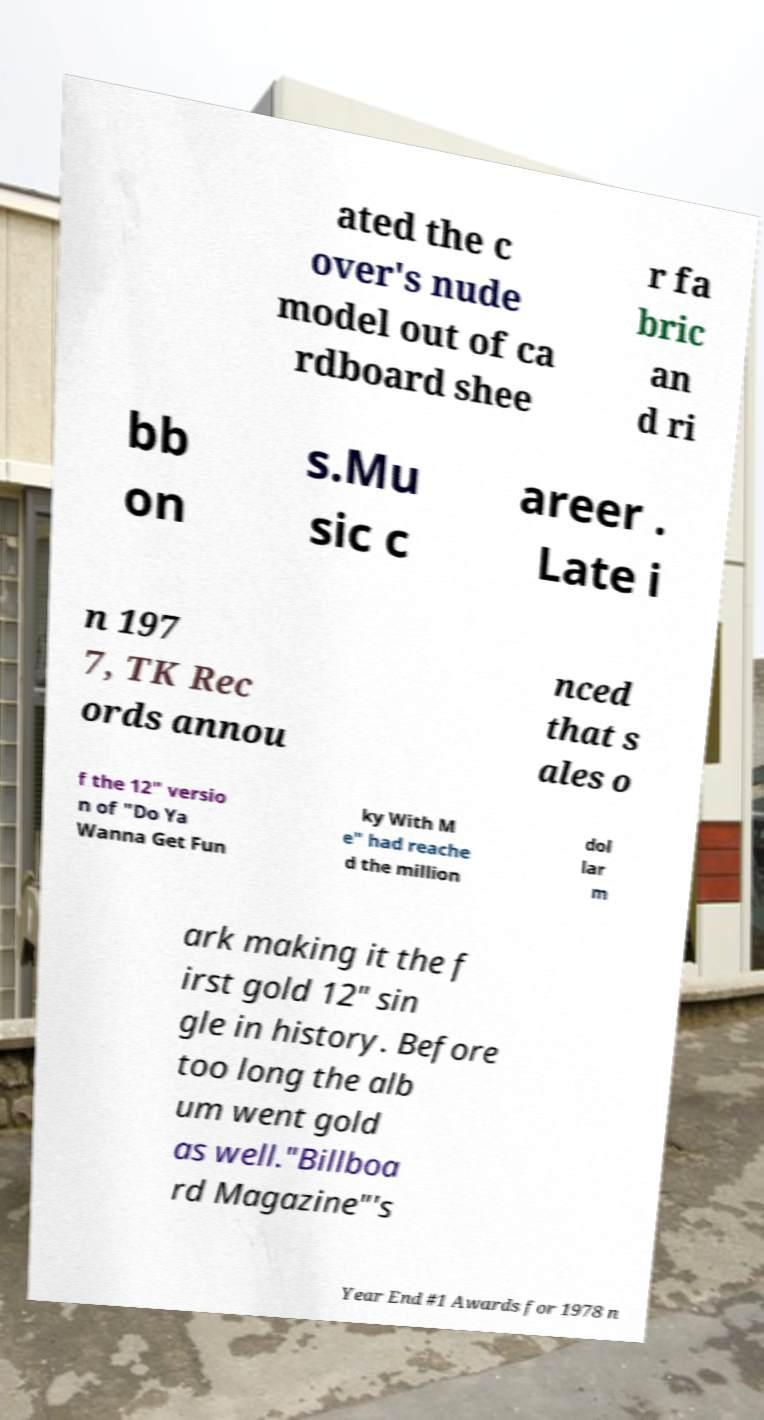Could you assist in decoding the text presented in this image and type it out clearly? ated the c over's nude model out of ca rdboard shee r fa bric an d ri bb on s.Mu sic c areer . Late i n 197 7, TK Rec ords annou nced that s ales o f the 12" versio n of "Do Ya Wanna Get Fun ky With M e" had reache d the million dol lar m ark making it the f irst gold 12" sin gle in history. Before too long the alb um went gold as well."Billboa rd Magazine"'s Year End #1 Awards for 1978 n 